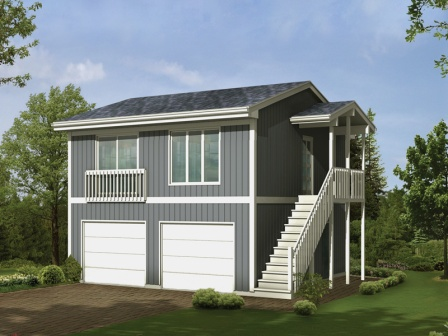I’d love to live in a place like this! What would be the daily life like? Daily life in this idyllic house would be filled with peaceful routines and a close connection to nature. Mornings would start with the soft glow of dawn filtering through the large windows, filling the home with natural light. You might enjoy a cup of coffee on the second-floor porch, overlooking the lush greenery, as birds serenade you. The tranquility of the surroundings provides a perfect setting for work-from-home days, creative pursuits, or simply unwinding after a long day. Evening walks along the brick driveway and nearby trails would become a cherished ritual, offering a moment of reflection and relaxation amidst the beauty of nature. It sounds so peaceful. Are there any nearby places worth visiting? Absolutely! Located just a short drive away is a charming town square bustling with artisan shops, cozy cafés, and a farmers' market offering fresh, local produce. For outdoor enthusiasts, a sprawling nature reserve nearby offers picturesque hiking trails, serene lakes for kayaking, and picnic spots perfect for family outings. Additionally, there's an old historic district where you can explore beautifully preserved buildings and learn about the area's rich history. This blend of serene living at home and vibrant community activities provides a perfect balance for a fulfilling lifestyle. 